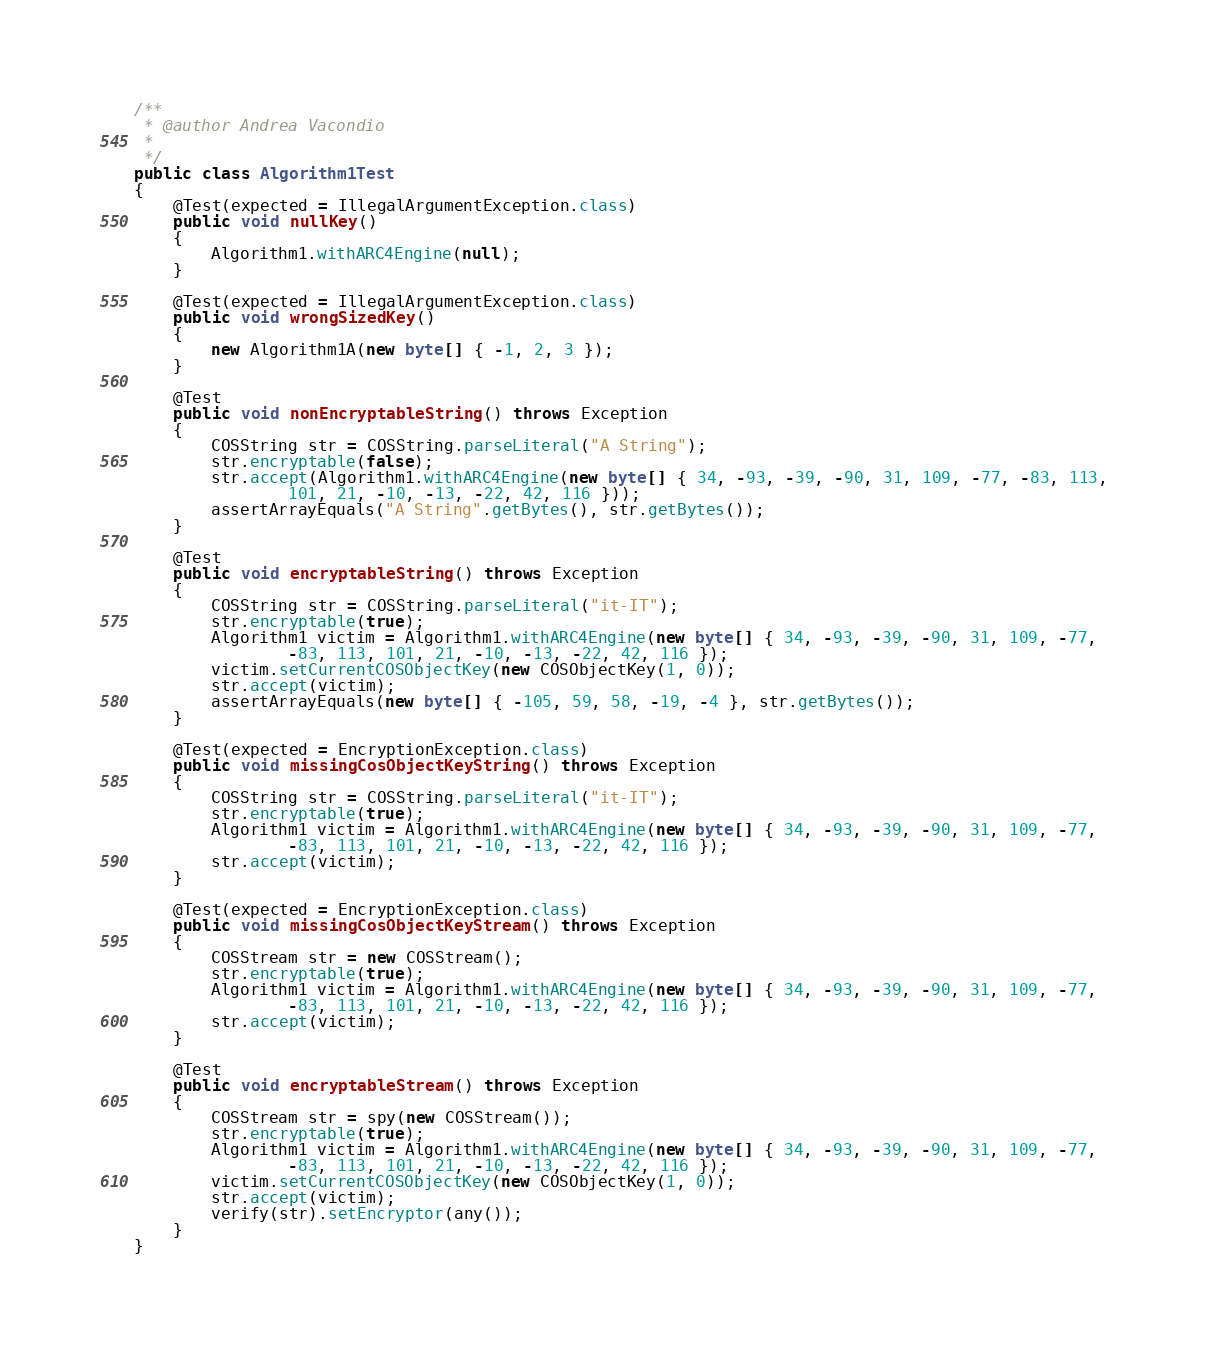<code> <loc_0><loc_0><loc_500><loc_500><_Java_>/**
 * @author Andrea Vacondio
 *
 */
public class Algorithm1Test
{
    @Test(expected = IllegalArgumentException.class)
    public void nullKey()
    {
        Algorithm1.withARC4Engine(null);
    }

    @Test(expected = IllegalArgumentException.class)
    public void wrongSizedKey()
    {
        new Algorithm1A(new byte[] { -1, 2, 3 });
    }

    @Test
    public void nonEncryptableString() throws Exception
    {
        COSString str = COSString.parseLiteral("A String");
        str.encryptable(false);
        str.accept(Algorithm1.withARC4Engine(new byte[] { 34, -93, -39, -90, 31, 109, -77, -83, 113,
                101, 21, -10, -13, -22, 42, 116 }));
        assertArrayEquals("A String".getBytes(), str.getBytes());
    }

    @Test
    public void encryptableString() throws Exception
    {
        COSString str = COSString.parseLiteral("it-IT");
        str.encryptable(true);
        Algorithm1 victim = Algorithm1.withARC4Engine(new byte[] { 34, -93, -39, -90, 31, 109, -77,
                -83, 113, 101, 21, -10, -13, -22, 42, 116 });
        victim.setCurrentCOSObjectKey(new COSObjectKey(1, 0));
        str.accept(victim);
        assertArrayEquals(new byte[] { -105, 59, 58, -19, -4 }, str.getBytes());
    }

    @Test(expected = EncryptionException.class)
    public void missingCosObjectKeyString() throws Exception
    {
        COSString str = COSString.parseLiteral("it-IT");
        str.encryptable(true);
        Algorithm1 victim = Algorithm1.withARC4Engine(new byte[] { 34, -93, -39, -90, 31, 109, -77,
                -83, 113, 101, 21, -10, -13, -22, 42, 116 });
        str.accept(victim);
    }

    @Test(expected = EncryptionException.class)
    public void missingCosObjectKeyStream() throws Exception
    {
        COSStream str = new COSStream();
        str.encryptable(true);
        Algorithm1 victim = Algorithm1.withARC4Engine(new byte[] { 34, -93, -39, -90, 31, 109, -77,
                -83, 113, 101, 21, -10, -13, -22, 42, 116 });
        str.accept(victim);
    }

    @Test
    public void encryptableStream() throws Exception
    {
        COSStream str = spy(new COSStream());
        str.encryptable(true);
        Algorithm1 victim = Algorithm1.withARC4Engine(new byte[] { 34, -93, -39, -90, 31, 109, -77,
                -83, 113, 101, 21, -10, -13, -22, 42, 116 });
        victim.setCurrentCOSObjectKey(new COSObjectKey(1, 0));
        str.accept(victim);
        verify(str).setEncryptor(any());
    }
}
</code> 